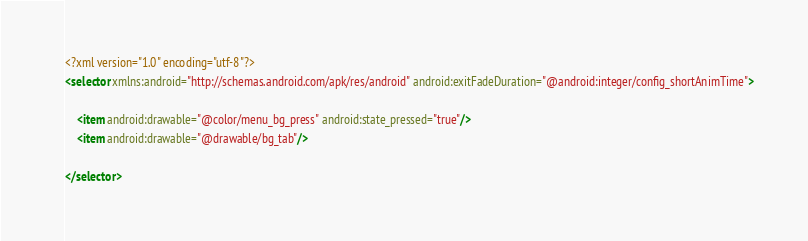Convert code to text. <code><loc_0><loc_0><loc_500><loc_500><_XML_><?xml version="1.0" encoding="utf-8"?>
<selector xmlns:android="http://schemas.android.com/apk/res/android" android:exitFadeDuration="@android:integer/config_shortAnimTime">

    <item android:drawable="@color/menu_bg_press" android:state_pressed="true"/>
    <item android:drawable="@drawable/bg_tab"/>

</selector></code> 